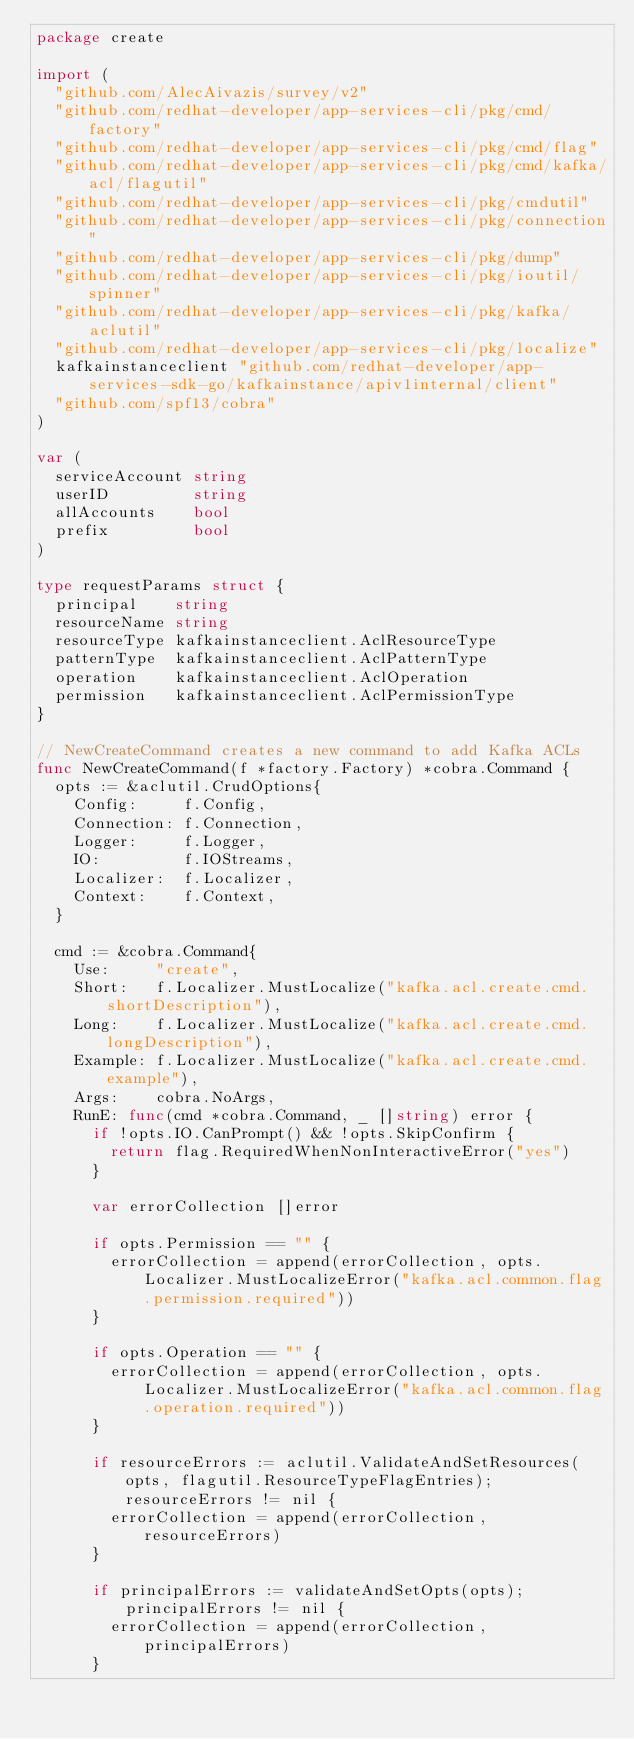Convert code to text. <code><loc_0><loc_0><loc_500><loc_500><_Go_>package create

import (
	"github.com/AlecAivazis/survey/v2"
	"github.com/redhat-developer/app-services-cli/pkg/cmd/factory"
	"github.com/redhat-developer/app-services-cli/pkg/cmd/flag"
	"github.com/redhat-developer/app-services-cli/pkg/cmd/kafka/acl/flagutil"
	"github.com/redhat-developer/app-services-cli/pkg/cmdutil"
	"github.com/redhat-developer/app-services-cli/pkg/connection"
	"github.com/redhat-developer/app-services-cli/pkg/dump"
	"github.com/redhat-developer/app-services-cli/pkg/ioutil/spinner"
	"github.com/redhat-developer/app-services-cli/pkg/kafka/aclutil"
	"github.com/redhat-developer/app-services-cli/pkg/localize"
	kafkainstanceclient "github.com/redhat-developer/app-services-sdk-go/kafkainstance/apiv1internal/client"
	"github.com/spf13/cobra"
)

var (
	serviceAccount string
	userID         string
	allAccounts    bool
	prefix         bool
)

type requestParams struct {
	principal    string
	resourceName string
	resourceType kafkainstanceclient.AclResourceType
	patternType  kafkainstanceclient.AclPatternType
	operation    kafkainstanceclient.AclOperation
	permission   kafkainstanceclient.AclPermissionType
}

// NewCreateCommand creates a new command to add Kafka ACLs
func NewCreateCommand(f *factory.Factory) *cobra.Command {
	opts := &aclutil.CrudOptions{
		Config:     f.Config,
		Connection: f.Connection,
		Logger:     f.Logger,
		IO:         f.IOStreams,
		Localizer:  f.Localizer,
		Context:    f.Context,
	}

	cmd := &cobra.Command{
		Use:     "create",
		Short:   f.Localizer.MustLocalize("kafka.acl.create.cmd.shortDescription"),
		Long:    f.Localizer.MustLocalize("kafka.acl.create.cmd.longDescription"),
		Example: f.Localizer.MustLocalize("kafka.acl.create.cmd.example"),
		Args:    cobra.NoArgs,
		RunE: func(cmd *cobra.Command, _ []string) error {
			if !opts.IO.CanPrompt() && !opts.SkipConfirm {
				return flag.RequiredWhenNonInteractiveError("yes")
			}

			var errorCollection []error

			if opts.Permission == "" {
				errorCollection = append(errorCollection, opts.Localizer.MustLocalizeError("kafka.acl.common.flag.permission.required"))
			}

			if opts.Operation == "" {
				errorCollection = append(errorCollection, opts.Localizer.MustLocalizeError("kafka.acl.common.flag.operation.required"))
			}

			if resourceErrors := aclutil.ValidateAndSetResources(opts, flagutil.ResourceTypeFlagEntries); resourceErrors != nil {
				errorCollection = append(errorCollection, resourceErrors)
			}

			if principalErrors := validateAndSetOpts(opts); principalErrors != nil {
				errorCollection = append(errorCollection, principalErrors)
			}
</code> 